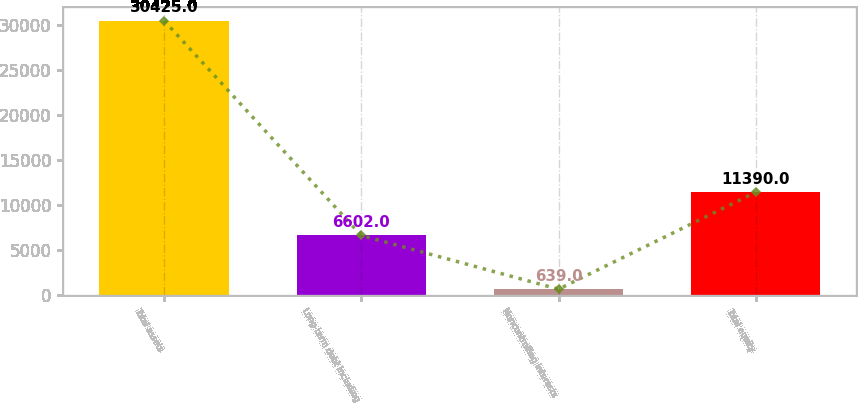Convert chart to OTSL. <chart><loc_0><loc_0><loc_500><loc_500><bar_chart><fcel>Total assets<fcel>Long-term debt including<fcel>Noncontrolling interests<fcel>Total equity<nl><fcel>30425<fcel>6602<fcel>639<fcel>11390<nl></chart> 